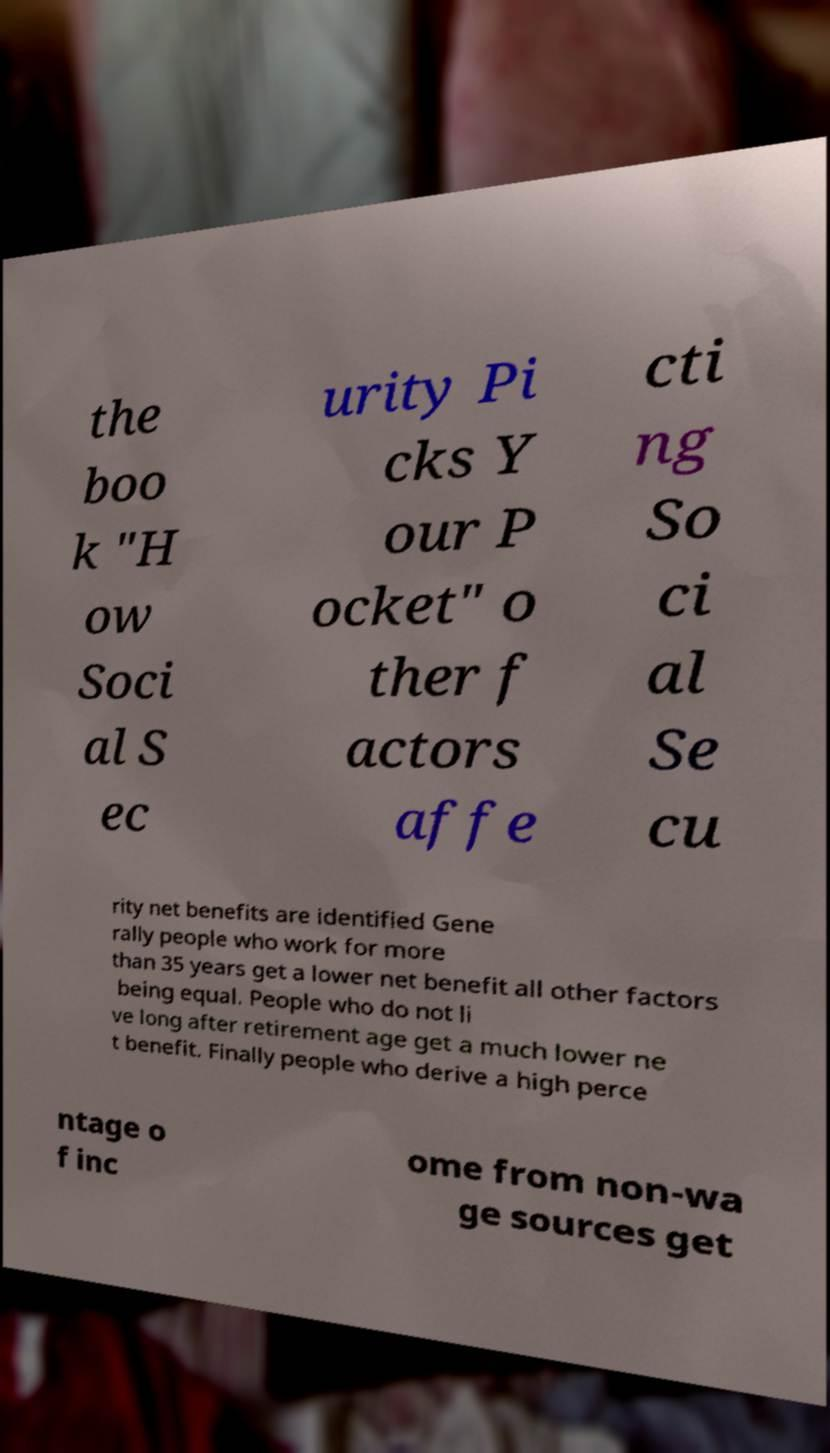Can you accurately transcribe the text from the provided image for me? the boo k "H ow Soci al S ec urity Pi cks Y our P ocket" o ther f actors affe cti ng So ci al Se cu rity net benefits are identified Gene rally people who work for more than 35 years get a lower net benefit all other factors being equal. People who do not li ve long after retirement age get a much lower ne t benefit. Finally people who derive a high perce ntage o f inc ome from non-wa ge sources get 